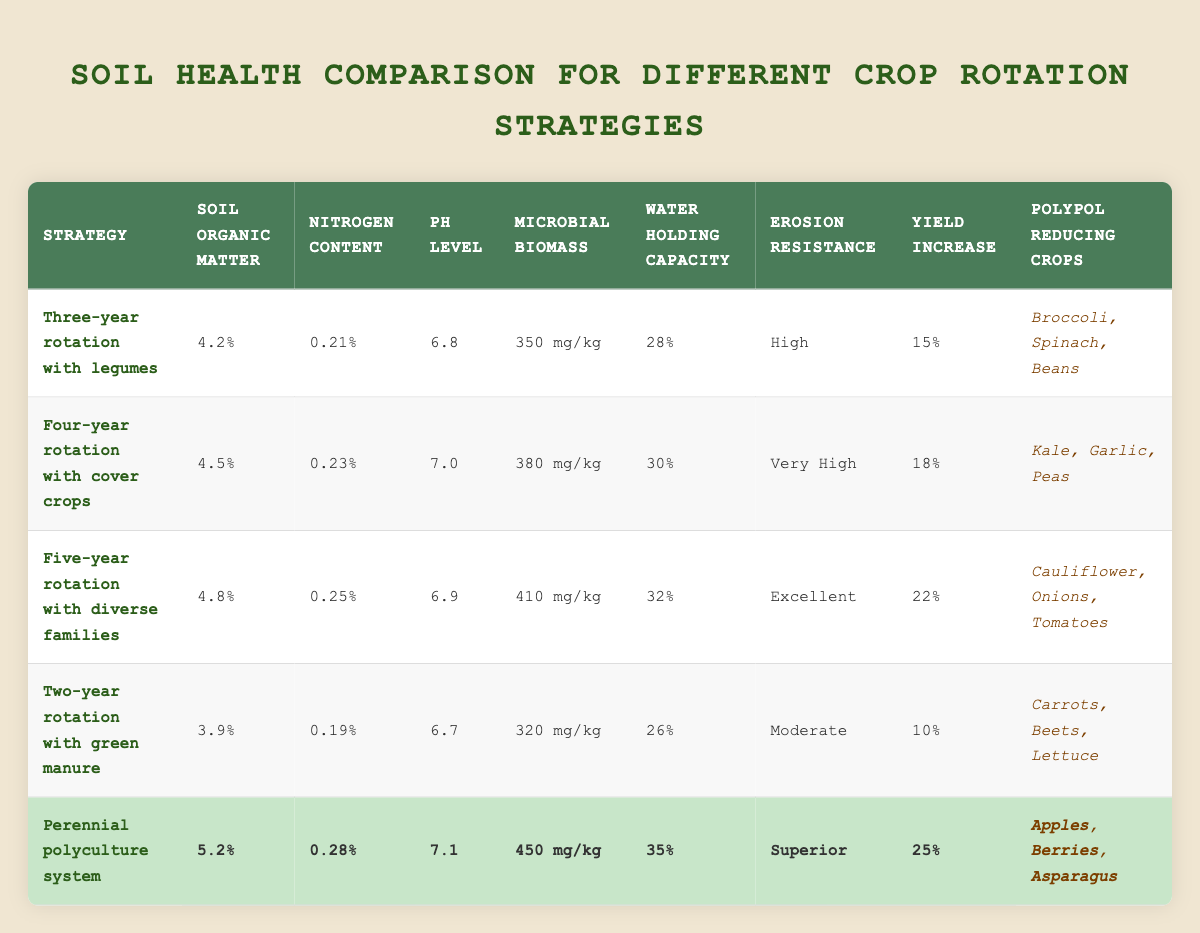What is the soil organic matter percentage for the Five-year rotation with diverse families strategy? The table directly states that the soil organic matter for the Five-year rotation with diverse families is 4.8%.
Answer: 4.8% Which crop rotation strategy has the highest water holding capacity? The table shows the water holding capacity for each strategy. Perennial polyculture system has the highest value at 35%.
Answer: 35% Is the nitrogen content in the Four-year rotation with cover crops higher than in the Two-year rotation with green manure? Comparing the nitrogen content of both strategies from the table, the Four-year rotation with cover crops has 0.23%, while the Two-year rotation with green manure has 0.19%. Since 0.23% > 0.19%, the statement is true.
Answer: Yes What is the average pH level for all listed crop rotation strategies? The pH levels from the table are: 6.8 (Three-year), 7.0 (Four-year), 6.9 (Five-year), 6.7 (Two-year), and 7.1 (Perennial). Summing them gives 6.8 + 7.0 + 6.9 + 6.7 + 7.1 = 34.5. Dividing by 5 gives an average of 34.5 / 5 = 6.9.
Answer: 6.9 Which strategy offers the most significant yield increase, according to the data? Looking at the yield increase column, the Perennial polyculture system offers the most significant increase at 25%.
Answer: 25% Does the Three-year rotation with legumes provide better erosion resistance than the Two-year rotation with green manure? The erosion resistance level for the Three-year rotation with legumes is High, while for the Two-year rotation with green manure, it is Moderate. Since High > Moderate, the statement is true.
Answer: Yes How many polypol reducing crops does the Five-year rotation with diverse families include? The Five-year rotation with diverse families lists three polypol reducing crops: Cauliflower, Onions, and Tomatoes.
Answer: 3 Calculate the difference in microbial biomass between the highest and lowest strategies. The highest microbial biomass is 450 mg/kg from the Perennial polyculture system, and the lowest is 320 mg/kg from the Two-year rotation with green manure. The difference is 450 - 320 = 130 mg/kg.
Answer: 130 mg/kg Which crop rotation strategy has the most diverse range of polypol reducing crops? By examining the table, the Five-year rotation with diverse families has three distinct crops (Cauliflower, Onions, Tomatoes), while the other strategies either have the same number or fewer.
Answer: Five-year rotation with diverse families 